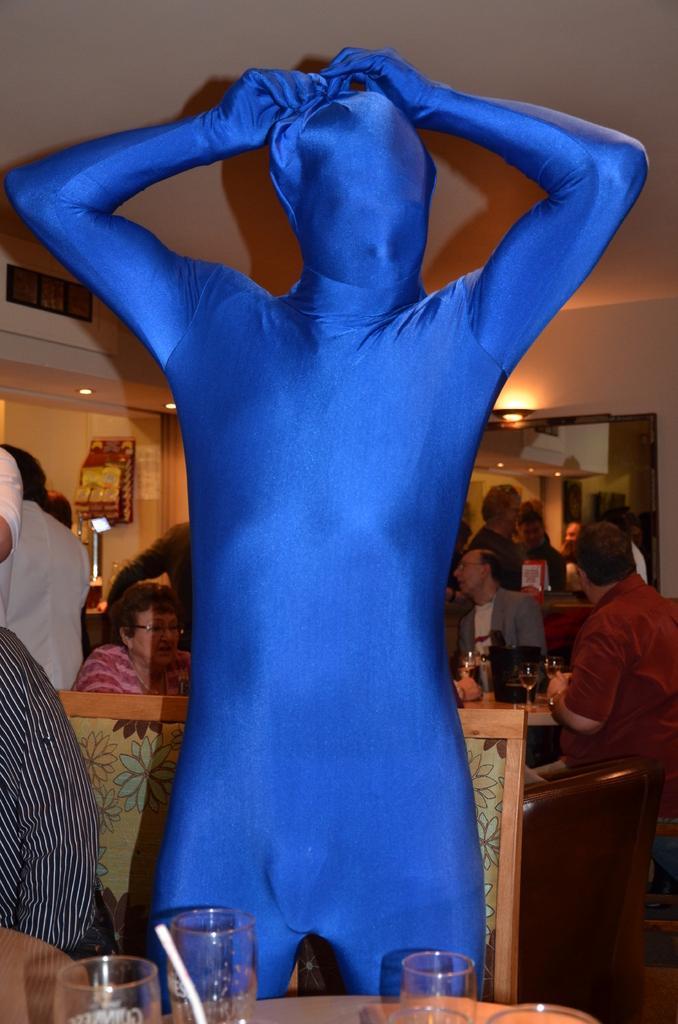Please provide a concise description of this image. In this picture we can see a group of people where some are sitting and some are standing here man in front wore blue color mask and in front of him we can see table and on table we have glasses, bowls and in background we can see wall, lights. 